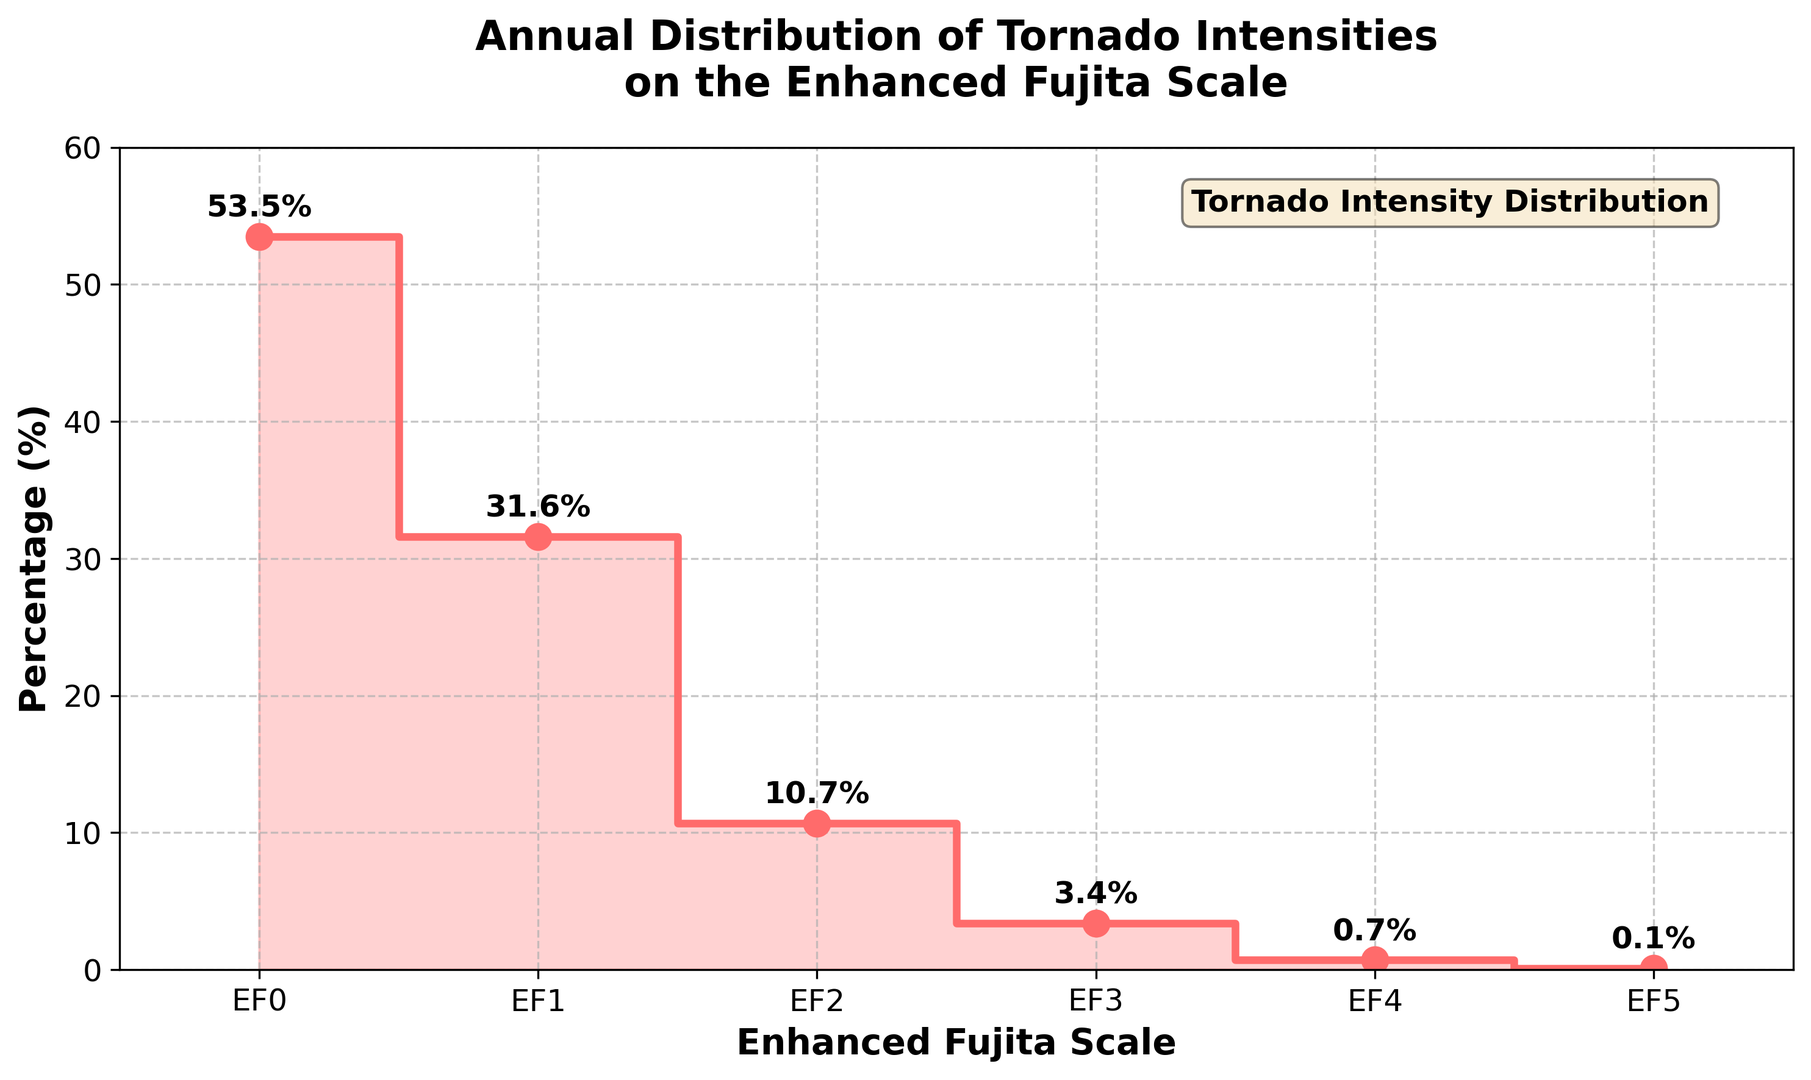Which EF-scale category has the highest percentage of tornadoes? The EF0 category has the highest percentage because the red step line reaches the highest point above the EF0 mark with a value of 53.5%.
Answer: EF0 What is the combined percentage for EF3, EF4, and EF5 tornadoes? Summing the percentages for EF3 (3.4%), EF4 (0.7%), and EF5 (0.1%) gives 3.4 + 0.7 + 0.1 = 4.2%.
Answer: 4.2% How does the percentage of EF0 tornadoes compare to the percentage of EF2 tornadoes? The percentage of EF0 tornadoes (53.5%) is significantly higher compared to EF2 tornadoes (10.7%). Subtracting the two, 53.5 - 10.7 = 42.8%.
Answer: 53.5% (EF0) is higher by 42.8% than 10.7% (EF2) What percentage of tornadoes are classified as EF1? The plot shows a red marker at the EF1 category corresponding to a height of 31.6% on the vertical axis.
Answer: 31.6% What is the difference in percentage between EF1 and EF3 tornadoes? Subtract the percentage for EF3 (3.4%) from the percentage for EF1 (31.6%) to find the difference: 31.6 - 3.4 = 28.2%.
Answer: 28.2% What percentage of tornadoes are categorized as EF4 or higher? Adding the percentages for EF4 (0.7%) and EF5 (0.1%) results in 0.7 + 0.1 = 0.8%.
Answer: 0.8% Which EF-scale categories have a percentage less than 5%? The categories EF3, EF4, and EF5 all have percentages below 5%, with values of 3.4%, 0.7%, and 0.1% respectively.
Answer: EF3, EF4, EF5 What is the combined percentage of EF0 and EF1 tornadoes? Adding the percentages for EF0 (53.5%) and EF1 (31.6%) gives 53.5 + 31.6 = 85.1%.
Answer: 85.1% Between EF2 and EF3 tornadoes, which category has a higher percentage? The red line is higher above the EF2 category (10.7%) than it is above the EF3 category (3.4%).
Answer: EF2 What is the average percentage for tornadoes in categories EF0, EF1, and EF2? Adding the percentages for EF0 (53.5%), EF1 (31.6%), and EF2 (10.7%) gives 53.5 + 31.6 + 10.7 = 95.8%, and then dividing by 3: 95.8 / 3 = 31.93%.
Answer: 31.93% 